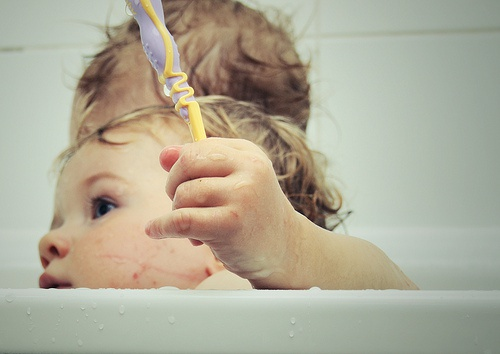Describe the objects in this image and their specific colors. I can see people in darkgray, tan, and gray tones, people in darkgray, tan, gray, brown, and maroon tones, and toothbrush in darkgray, khaki, and lightgray tones in this image. 